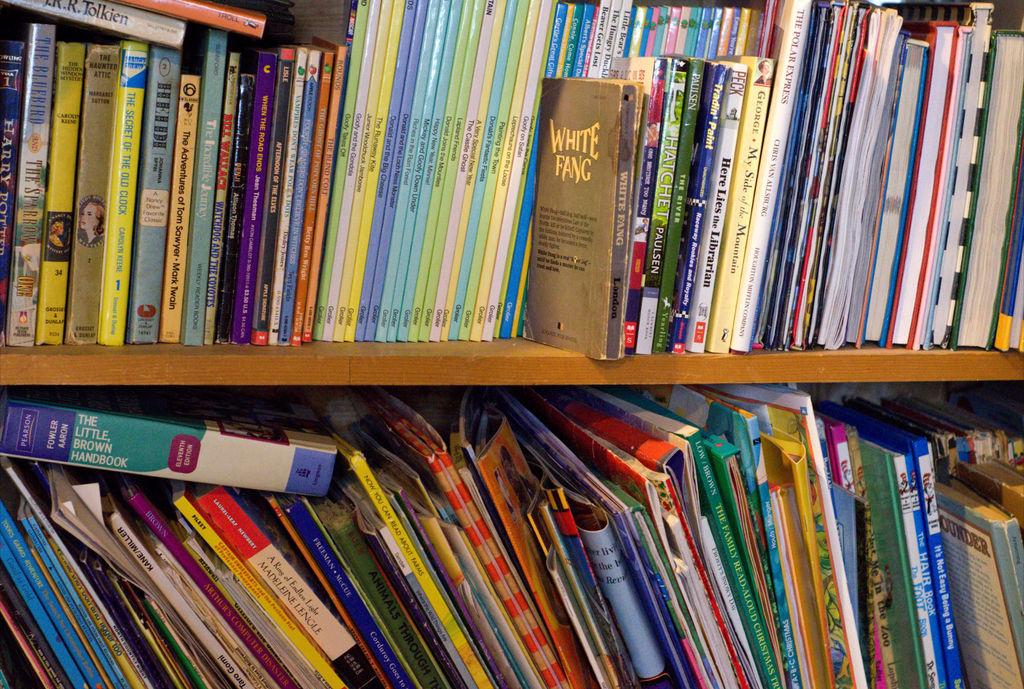What is the title of the brown book on the shelf?
Your answer should be compact. White fang. What is one of the books called?
Give a very brief answer. White fang. 